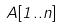Convert formula to latex. <formula><loc_0><loc_0><loc_500><loc_500>A [ 1 . . n ]</formula> 